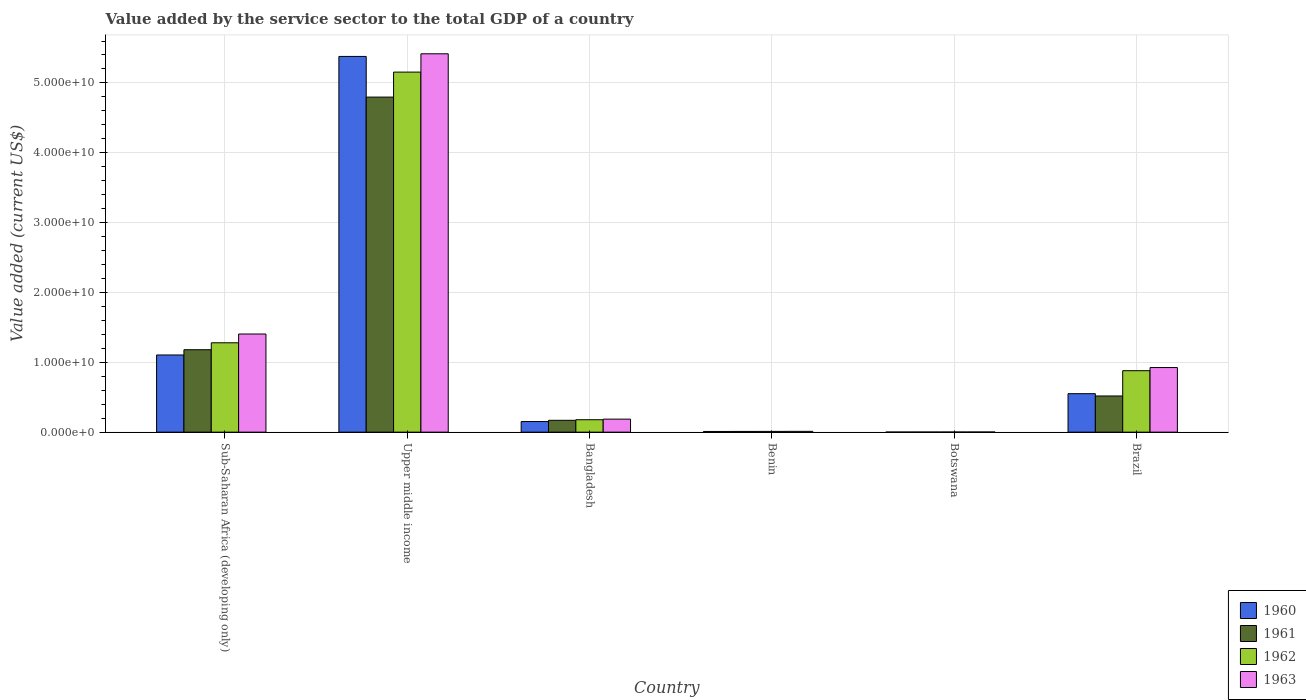How many different coloured bars are there?
Make the answer very short. 4. How many bars are there on the 5th tick from the right?
Your answer should be compact. 4. What is the label of the 1st group of bars from the left?
Your response must be concise. Sub-Saharan Africa (developing only). What is the value added by the service sector to the total GDP in 1962 in Bangladesh?
Give a very brief answer. 1.78e+09. Across all countries, what is the maximum value added by the service sector to the total GDP in 1960?
Give a very brief answer. 5.38e+1. Across all countries, what is the minimum value added by the service sector to the total GDP in 1961?
Provide a succinct answer. 1.51e+07. In which country was the value added by the service sector to the total GDP in 1962 maximum?
Your answer should be compact. Upper middle income. In which country was the value added by the service sector to the total GDP in 1961 minimum?
Make the answer very short. Botswana. What is the total value added by the service sector to the total GDP in 1962 in the graph?
Keep it short and to the point. 7.50e+1. What is the difference between the value added by the service sector to the total GDP in 1963 in Botswana and that in Upper middle income?
Ensure brevity in your answer.  -5.42e+1. What is the difference between the value added by the service sector to the total GDP in 1961 in Benin and the value added by the service sector to the total GDP in 1963 in Sub-Saharan Africa (developing only)?
Provide a succinct answer. -1.39e+1. What is the average value added by the service sector to the total GDP in 1962 per country?
Ensure brevity in your answer.  1.25e+1. What is the difference between the value added by the service sector to the total GDP of/in 1960 and value added by the service sector to the total GDP of/in 1963 in Sub-Saharan Africa (developing only)?
Your answer should be very brief. -3.00e+09. In how many countries, is the value added by the service sector to the total GDP in 1962 greater than 16000000000 US$?
Your answer should be compact. 1. What is the ratio of the value added by the service sector to the total GDP in 1962 in Botswana to that in Upper middle income?
Offer a very short reply. 0. What is the difference between the highest and the second highest value added by the service sector to the total GDP in 1960?
Offer a very short reply. -4.83e+1. What is the difference between the highest and the lowest value added by the service sector to the total GDP in 1963?
Your response must be concise. 5.42e+1. In how many countries, is the value added by the service sector to the total GDP in 1961 greater than the average value added by the service sector to the total GDP in 1961 taken over all countries?
Your answer should be very brief. 2. Is it the case that in every country, the sum of the value added by the service sector to the total GDP in 1963 and value added by the service sector to the total GDP in 1960 is greater than the sum of value added by the service sector to the total GDP in 1961 and value added by the service sector to the total GDP in 1962?
Provide a succinct answer. No. What does the 1st bar from the right in Bangladesh represents?
Offer a very short reply. 1963. How many bars are there?
Your response must be concise. 24. Are all the bars in the graph horizontal?
Ensure brevity in your answer.  No. How many countries are there in the graph?
Your response must be concise. 6. What is the difference between two consecutive major ticks on the Y-axis?
Provide a short and direct response. 1.00e+1. Does the graph contain any zero values?
Offer a very short reply. No. Does the graph contain grids?
Provide a short and direct response. Yes. How are the legend labels stacked?
Keep it short and to the point. Vertical. What is the title of the graph?
Give a very brief answer. Value added by the service sector to the total GDP of a country. Does "1971" appear as one of the legend labels in the graph?
Offer a very short reply. No. What is the label or title of the Y-axis?
Your response must be concise. Value added (current US$). What is the Value added (current US$) of 1960 in Sub-Saharan Africa (developing only)?
Provide a succinct answer. 1.10e+1. What is the Value added (current US$) of 1961 in Sub-Saharan Africa (developing only)?
Your answer should be compact. 1.18e+1. What is the Value added (current US$) of 1962 in Sub-Saharan Africa (developing only)?
Offer a very short reply. 1.28e+1. What is the Value added (current US$) in 1963 in Sub-Saharan Africa (developing only)?
Ensure brevity in your answer.  1.41e+1. What is the Value added (current US$) in 1960 in Upper middle income?
Provide a succinct answer. 5.38e+1. What is the Value added (current US$) in 1961 in Upper middle income?
Offer a terse response. 4.80e+1. What is the Value added (current US$) in 1962 in Upper middle income?
Make the answer very short. 5.16e+1. What is the Value added (current US$) of 1963 in Upper middle income?
Offer a terse response. 5.42e+1. What is the Value added (current US$) in 1960 in Bangladesh?
Your answer should be very brief. 1.52e+09. What is the Value added (current US$) of 1961 in Bangladesh?
Provide a short and direct response. 1.70e+09. What is the Value added (current US$) in 1962 in Bangladesh?
Offer a terse response. 1.78e+09. What is the Value added (current US$) of 1963 in Bangladesh?
Provide a succinct answer. 1.86e+09. What is the Value added (current US$) in 1960 in Benin?
Provide a short and direct response. 9.87e+07. What is the Value added (current US$) of 1961 in Benin?
Offer a very short reply. 1.04e+08. What is the Value added (current US$) of 1962 in Benin?
Ensure brevity in your answer.  1.08e+08. What is the Value added (current US$) in 1963 in Benin?
Offer a very short reply. 1.14e+08. What is the Value added (current US$) in 1960 in Botswana?
Keep it short and to the point. 1.31e+07. What is the Value added (current US$) in 1961 in Botswana?
Keep it short and to the point. 1.51e+07. What is the Value added (current US$) in 1962 in Botswana?
Offer a terse response. 1.73e+07. What is the Value added (current US$) in 1963 in Botswana?
Your response must be concise. 1.93e+07. What is the Value added (current US$) of 1960 in Brazil?
Your answer should be compact. 5.51e+09. What is the Value added (current US$) in 1961 in Brazil?
Provide a succinct answer. 5.18e+09. What is the Value added (current US$) of 1962 in Brazil?
Give a very brief answer. 8.80e+09. What is the Value added (current US$) of 1963 in Brazil?
Offer a terse response. 9.25e+09. Across all countries, what is the maximum Value added (current US$) of 1960?
Give a very brief answer. 5.38e+1. Across all countries, what is the maximum Value added (current US$) of 1961?
Ensure brevity in your answer.  4.80e+1. Across all countries, what is the maximum Value added (current US$) of 1962?
Your answer should be compact. 5.16e+1. Across all countries, what is the maximum Value added (current US$) in 1963?
Give a very brief answer. 5.42e+1. Across all countries, what is the minimum Value added (current US$) of 1960?
Offer a very short reply. 1.31e+07. Across all countries, what is the minimum Value added (current US$) of 1961?
Provide a succinct answer. 1.51e+07. Across all countries, what is the minimum Value added (current US$) of 1962?
Provide a succinct answer. 1.73e+07. Across all countries, what is the minimum Value added (current US$) of 1963?
Give a very brief answer. 1.93e+07. What is the total Value added (current US$) in 1960 in the graph?
Make the answer very short. 7.20e+1. What is the total Value added (current US$) of 1961 in the graph?
Your answer should be compact. 6.68e+1. What is the total Value added (current US$) in 1962 in the graph?
Make the answer very short. 7.50e+1. What is the total Value added (current US$) of 1963 in the graph?
Provide a succinct answer. 7.95e+1. What is the difference between the Value added (current US$) of 1960 in Sub-Saharan Africa (developing only) and that in Upper middle income?
Give a very brief answer. -4.27e+1. What is the difference between the Value added (current US$) in 1961 in Sub-Saharan Africa (developing only) and that in Upper middle income?
Your answer should be compact. -3.62e+1. What is the difference between the Value added (current US$) of 1962 in Sub-Saharan Africa (developing only) and that in Upper middle income?
Provide a short and direct response. -3.88e+1. What is the difference between the Value added (current US$) of 1963 in Sub-Saharan Africa (developing only) and that in Upper middle income?
Provide a short and direct response. -4.01e+1. What is the difference between the Value added (current US$) of 1960 in Sub-Saharan Africa (developing only) and that in Bangladesh?
Ensure brevity in your answer.  9.53e+09. What is the difference between the Value added (current US$) of 1961 in Sub-Saharan Africa (developing only) and that in Bangladesh?
Provide a short and direct response. 1.01e+1. What is the difference between the Value added (current US$) in 1962 in Sub-Saharan Africa (developing only) and that in Bangladesh?
Offer a terse response. 1.10e+1. What is the difference between the Value added (current US$) in 1963 in Sub-Saharan Africa (developing only) and that in Bangladesh?
Offer a terse response. 1.22e+1. What is the difference between the Value added (current US$) of 1960 in Sub-Saharan Africa (developing only) and that in Benin?
Give a very brief answer. 1.10e+1. What is the difference between the Value added (current US$) of 1961 in Sub-Saharan Africa (developing only) and that in Benin?
Keep it short and to the point. 1.17e+1. What is the difference between the Value added (current US$) of 1962 in Sub-Saharan Africa (developing only) and that in Benin?
Your response must be concise. 1.27e+1. What is the difference between the Value added (current US$) of 1963 in Sub-Saharan Africa (developing only) and that in Benin?
Offer a very short reply. 1.39e+1. What is the difference between the Value added (current US$) of 1960 in Sub-Saharan Africa (developing only) and that in Botswana?
Offer a very short reply. 1.10e+1. What is the difference between the Value added (current US$) in 1961 in Sub-Saharan Africa (developing only) and that in Botswana?
Your answer should be compact. 1.18e+1. What is the difference between the Value added (current US$) of 1962 in Sub-Saharan Africa (developing only) and that in Botswana?
Ensure brevity in your answer.  1.28e+1. What is the difference between the Value added (current US$) in 1963 in Sub-Saharan Africa (developing only) and that in Botswana?
Provide a succinct answer. 1.40e+1. What is the difference between the Value added (current US$) of 1960 in Sub-Saharan Africa (developing only) and that in Brazil?
Your answer should be compact. 5.54e+09. What is the difference between the Value added (current US$) of 1961 in Sub-Saharan Africa (developing only) and that in Brazil?
Provide a succinct answer. 6.62e+09. What is the difference between the Value added (current US$) in 1962 in Sub-Saharan Africa (developing only) and that in Brazil?
Provide a short and direct response. 4.00e+09. What is the difference between the Value added (current US$) in 1963 in Sub-Saharan Africa (developing only) and that in Brazil?
Provide a succinct answer. 4.80e+09. What is the difference between the Value added (current US$) of 1960 in Upper middle income and that in Bangladesh?
Your response must be concise. 5.23e+1. What is the difference between the Value added (current US$) in 1961 in Upper middle income and that in Bangladesh?
Provide a succinct answer. 4.63e+1. What is the difference between the Value added (current US$) of 1962 in Upper middle income and that in Bangladesh?
Provide a succinct answer. 4.98e+1. What is the difference between the Value added (current US$) in 1963 in Upper middle income and that in Bangladesh?
Offer a terse response. 5.23e+1. What is the difference between the Value added (current US$) in 1960 in Upper middle income and that in Benin?
Offer a terse response. 5.37e+1. What is the difference between the Value added (current US$) in 1961 in Upper middle income and that in Benin?
Your answer should be very brief. 4.79e+1. What is the difference between the Value added (current US$) in 1962 in Upper middle income and that in Benin?
Keep it short and to the point. 5.14e+1. What is the difference between the Value added (current US$) of 1963 in Upper middle income and that in Benin?
Make the answer very short. 5.41e+1. What is the difference between the Value added (current US$) in 1960 in Upper middle income and that in Botswana?
Keep it short and to the point. 5.38e+1. What is the difference between the Value added (current US$) in 1961 in Upper middle income and that in Botswana?
Ensure brevity in your answer.  4.80e+1. What is the difference between the Value added (current US$) of 1962 in Upper middle income and that in Botswana?
Offer a terse response. 5.15e+1. What is the difference between the Value added (current US$) of 1963 in Upper middle income and that in Botswana?
Offer a terse response. 5.42e+1. What is the difference between the Value added (current US$) in 1960 in Upper middle income and that in Brazil?
Ensure brevity in your answer.  4.83e+1. What is the difference between the Value added (current US$) of 1961 in Upper middle income and that in Brazil?
Provide a short and direct response. 4.28e+1. What is the difference between the Value added (current US$) of 1962 in Upper middle income and that in Brazil?
Make the answer very short. 4.28e+1. What is the difference between the Value added (current US$) in 1963 in Upper middle income and that in Brazil?
Ensure brevity in your answer.  4.49e+1. What is the difference between the Value added (current US$) of 1960 in Bangladesh and that in Benin?
Provide a short and direct response. 1.42e+09. What is the difference between the Value added (current US$) in 1961 in Bangladesh and that in Benin?
Make the answer very short. 1.59e+09. What is the difference between the Value added (current US$) of 1962 in Bangladesh and that in Benin?
Make the answer very short. 1.67e+09. What is the difference between the Value added (current US$) of 1963 in Bangladesh and that in Benin?
Your response must be concise. 1.75e+09. What is the difference between the Value added (current US$) in 1960 in Bangladesh and that in Botswana?
Keep it short and to the point. 1.51e+09. What is the difference between the Value added (current US$) of 1961 in Bangladesh and that in Botswana?
Offer a terse response. 1.68e+09. What is the difference between the Value added (current US$) in 1962 in Bangladesh and that in Botswana?
Provide a succinct answer. 1.76e+09. What is the difference between the Value added (current US$) of 1963 in Bangladesh and that in Botswana?
Provide a succinct answer. 1.85e+09. What is the difference between the Value added (current US$) of 1960 in Bangladesh and that in Brazil?
Provide a short and direct response. -3.99e+09. What is the difference between the Value added (current US$) in 1961 in Bangladesh and that in Brazil?
Your response must be concise. -3.48e+09. What is the difference between the Value added (current US$) of 1962 in Bangladesh and that in Brazil?
Give a very brief answer. -7.02e+09. What is the difference between the Value added (current US$) of 1963 in Bangladesh and that in Brazil?
Make the answer very short. -7.38e+09. What is the difference between the Value added (current US$) of 1960 in Benin and that in Botswana?
Give a very brief answer. 8.55e+07. What is the difference between the Value added (current US$) of 1961 in Benin and that in Botswana?
Give a very brief answer. 8.86e+07. What is the difference between the Value added (current US$) of 1962 in Benin and that in Botswana?
Your answer should be compact. 9.03e+07. What is the difference between the Value added (current US$) of 1963 in Benin and that in Botswana?
Offer a terse response. 9.45e+07. What is the difference between the Value added (current US$) of 1960 in Benin and that in Brazil?
Give a very brief answer. -5.41e+09. What is the difference between the Value added (current US$) in 1961 in Benin and that in Brazil?
Keep it short and to the point. -5.07e+09. What is the difference between the Value added (current US$) of 1962 in Benin and that in Brazil?
Your answer should be compact. -8.69e+09. What is the difference between the Value added (current US$) of 1963 in Benin and that in Brazil?
Offer a very short reply. -9.13e+09. What is the difference between the Value added (current US$) of 1960 in Botswana and that in Brazil?
Provide a short and direct response. -5.50e+09. What is the difference between the Value added (current US$) of 1961 in Botswana and that in Brazil?
Provide a succinct answer. -5.16e+09. What is the difference between the Value added (current US$) of 1962 in Botswana and that in Brazil?
Provide a short and direct response. -8.78e+09. What is the difference between the Value added (current US$) of 1963 in Botswana and that in Brazil?
Provide a succinct answer. -9.23e+09. What is the difference between the Value added (current US$) of 1960 in Sub-Saharan Africa (developing only) and the Value added (current US$) of 1961 in Upper middle income?
Your response must be concise. -3.69e+1. What is the difference between the Value added (current US$) in 1960 in Sub-Saharan Africa (developing only) and the Value added (current US$) in 1962 in Upper middle income?
Give a very brief answer. -4.05e+1. What is the difference between the Value added (current US$) in 1960 in Sub-Saharan Africa (developing only) and the Value added (current US$) in 1963 in Upper middle income?
Your answer should be very brief. -4.31e+1. What is the difference between the Value added (current US$) of 1961 in Sub-Saharan Africa (developing only) and the Value added (current US$) of 1962 in Upper middle income?
Your answer should be compact. -3.97e+1. What is the difference between the Value added (current US$) in 1961 in Sub-Saharan Africa (developing only) and the Value added (current US$) in 1963 in Upper middle income?
Your answer should be compact. -4.24e+1. What is the difference between the Value added (current US$) in 1962 in Sub-Saharan Africa (developing only) and the Value added (current US$) in 1963 in Upper middle income?
Provide a succinct answer. -4.14e+1. What is the difference between the Value added (current US$) in 1960 in Sub-Saharan Africa (developing only) and the Value added (current US$) in 1961 in Bangladesh?
Your answer should be very brief. 9.35e+09. What is the difference between the Value added (current US$) in 1960 in Sub-Saharan Africa (developing only) and the Value added (current US$) in 1962 in Bangladesh?
Your response must be concise. 9.27e+09. What is the difference between the Value added (current US$) in 1960 in Sub-Saharan Africa (developing only) and the Value added (current US$) in 1963 in Bangladesh?
Give a very brief answer. 9.19e+09. What is the difference between the Value added (current US$) in 1961 in Sub-Saharan Africa (developing only) and the Value added (current US$) in 1962 in Bangladesh?
Provide a succinct answer. 1.00e+1. What is the difference between the Value added (current US$) in 1961 in Sub-Saharan Africa (developing only) and the Value added (current US$) in 1963 in Bangladesh?
Ensure brevity in your answer.  9.94e+09. What is the difference between the Value added (current US$) in 1962 in Sub-Saharan Africa (developing only) and the Value added (current US$) in 1963 in Bangladesh?
Your answer should be compact. 1.09e+1. What is the difference between the Value added (current US$) in 1960 in Sub-Saharan Africa (developing only) and the Value added (current US$) in 1961 in Benin?
Your answer should be very brief. 1.09e+1. What is the difference between the Value added (current US$) in 1960 in Sub-Saharan Africa (developing only) and the Value added (current US$) in 1962 in Benin?
Offer a terse response. 1.09e+1. What is the difference between the Value added (current US$) in 1960 in Sub-Saharan Africa (developing only) and the Value added (current US$) in 1963 in Benin?
Offer a very short reply. 1.09e+1. What is the difference between the Value added (current US$) of 1961 in Sub-Saharan Africa (developing only) and the Value added (current US$) of 1962 in Benin?
Provide a succinct answer. 1.17e+1. What is the difference between the Value added (current US$) of 1961 in Sub-Saharan Africa (developing only) and the Value added (current US$) of 1963 in Benin?
Ensure brevity in your answer.  1.17e+1. What is the difference between the Value added (current US$) of 1962 in Sub-Saharan Africa (developing only) and the Value added (current US$) of 1963 in Benin?
Keep it short and to the point. 1.27e+1. What is the difference between the Value added (current US$) in 1960 in Sub-Saharan Africa (developing only) and the Value added (current US$) in 1961 in Botswana?
Your answer should be very brief. 1.10e+1. What is the difference between the Value added (current US$) of 1960 in Sub-Saharan Africa (developing only) and the Value added (current US$) of 1962 in Botswana?
Your answer should be very brief. 1.10e+1. What is the difference between the Value added (current US$) of 1960 in Sub-Saharan Africa (developing only) and the Value added (current US$) of 1963 in Botswana?
Provide a succinct answer. 1.10e+1. What is the difference between the Value added (current US$) of 1961 in Sub-Saharan Africa (developing only) and the Value added (current US$) of 1962 in Botswana?
Give a very brief answer. 1.18e+1. What is the difference between the Value added (current US$) of 1961 in Sub-Saharan Africa (developing only) and the Value added (current US$) of 1963 in Botswana?
Make the answer very short. 1.18e+1. What is the difference between the Value added (current US$) in 1962 in Sub-Saharan Africa (developing only) and the Value added (current US$) in 1963 in Botswana?
Your answer should be compact. 1.28e+1. What is the difference between the Value added (current US$) in 1960 in Sub-Saharan Africa (developing only) and the Value added (current US$) in 1961 in Brazil?
Offer a very short reply. 5.87e+09. What is the difference between the Value added (current US$) in 1960 in Sub-Saharan Africa (developing only) and the Value added (current US$) in 1962 in Brazil?
Provide a succinct answer. 2.25e+09. What is the difference between the Value added (current US$) of 1960 in Sub-Saharan Africa (developing only) and the Value added (current US$) of 1963 in Brazil?
Make the answer very short. 1.80e+09. What is the difference between the Value added (current US$) in 1961 in Sub-Saharan Africa (developing only) and the Value added (current US$) in 1962 in Brazil?
Ensure brevity in your answer.  3.00e+09. What is the difference between the Value added (current US$) in 1961 in Sub-Saharan Africa (developing only) and the Value added (current US$) in 1963 in Brazil?
Offer a very short reply. 2.55e+09. What is the difference between the Value added (current US$) in 1962 in Sub-Saharan Africa (developing only) and the Value added (current US$) in 1963 in Brazil?
Your answer should be compact. 3.55e+09. What is the difference between the Value added (current US$) in 1960 in Upper middle income and the Value added (current US$) in 1961 in Bangladesh?
Make the answer very short. 5.21e+1. What is the difference between the Value added (current US$) of 1960 in Upper middle income and the Value added (current US$) of 1962 in Bangladesh?
Your answer should be very brief. 5.20e+1. What is the difference between the Value added (current US$) in 1960 in Upper middle income and the Value added (current US$) in 1963 in Bangladesh?
Provide a short and direct response. 5.19e+1. What is the difference between the Value added (current US$) in 1961 in Upper middle income and the Value added (current US$) in 1962 in Bangladesh?
Provide a short and direct response. 4.62e+1. What is the difference between the Value added (current US$) of 1961 in Upper middle income and the Value added (current US$) of 1963 in Bangladesh?
Your answer should be very brief. 4.61e+1. What is the difference between the Value added (current US$) of 1962 in Upper middle income and the Value added (current US$) of 1963 in Bangladesh?
Provide a succinct answer. 4.97e+1. What is the difference between the Value added (current US$) in 1960 in Upper middle income and the Value added (current US$) in 1961 in Benin?
Your answer should be very brief. 5.37e+1. What is the difference between the Value added (current US$) of 1960 in Upper middle income and the Value added (current US$) of 1962 in Benin?
Make the answer very short. 5.37e+1. What is the difference between the Value added (current US$) of 1960 in Upper middle income and the Value added (current US$) of 1963 in Benin?
Give a very brief answer. 5.37e+1. What is the difference between the Value added (current US$) of 1961 in Upper middle income and the Value added (current US$) of 1962 in Benin?
Offer a terse response. 4.79e+1. What is the difference between the Value added (current US$) in 1961 in Upper middle income and the Value added (current US$) in 1963 in Benin?
Your answer should be very brief. 4.79e+1. What is the difference between the Value added (current US$) in 1962 in Upper middle income and the Value added (current US$) in 1963 in Benin?
Ensure brevity in your answer.  5.14e+1. What is the difference between the Value added (current US$) in 1960 in Upper middle income and the Value added (current US$) in 1961 in Botswana?
Offer a very short reply. 5.38e+1. What is the difference between the Value added (current US$) in 1960 in Upper middle income and the Value added (current US$) in 1962 in Botswana?
Offer a very short reply. 5.38e+1. What is the difference between the Value added (current US$) of 1960 in Upper middle income and the Value added (current US$) of 1963 in Botswana?
Offer a very short reply. 5.38e+1. What is the difference between the Value added (current US$) of 1961 in Upper middle income and the Value added (current US$) of 1962 in Botswana?
Keep it short and to the point. 4.80e+1. What is the difference between the Value added (current US$) of 1961 in Upper middle income and the Value added (current US$) of 1963 in Botswana?
Offer a very short reply. 4.80e+1. What is the difference between the Value added (current US$) in 1962 in Upper middle income and the Value added (current US$) in 1963 in Botswana?
Your response must be concise. 5.15e+1. What is the difference between the Value added (current US$) of 1960 in Upper middle income and the Value added (current US$) of 1961 in Brazil?
Your answer should be compact. 4.86e+1. What is the difference between the Value added (current US$) of 1960 in Upper middle income and the Value added (current US$) of 1962 in Brazil?
Ensure brevity in your answer.  4.50e+1. What is the difference between the Value added (current US$) of 1960 in Upper middle income and the Value added (current US$) of 1963 in Brazil?
Provide a succinct answer. 4.45e+1. What is the difference between the Value added (current US$) in 1961 in Upper middle income and the Value added (current US$) in 1962 in Brazil?
Make the answer very short. 3.92e+1. What is the difference between the Value added (current US$) of 1961 in Upper middle income and the Value added (current US$) of 1963 in Brazil?
Make the answer very short. 3.87e+1. What is the difference between the Value added (current US$) in 1962 in Upper middle income and the Value added (current US$) in 1963 in Brazil?
Your answer should be compact. 4.23e+1. What is the difference between the Value added (current US$) in 1960 in Bangladesh and the Value added (current US$) in 1961 in Benin?
Offer a very short reply. 1.42e+09. What is the difference between the Value added (current US$) of 1960 in Bangladesh and the Value added (current US$) of 1962 in Benin?
Provide a succinct answer. 1.41e+09. What is the difference between the Value added (current US$) of 1960 in Bangladesh and the Value added (current US$) of 1963 in Benin?
Keep it short and to the point. 1.41e+09. What is the difference between the Value added (current US$) of 1961 in Bangladesh and the Value added (current US$) of 1962 in Benin?
Offer a terse response. 1.59e+09. What is the difference between the Value added (current US$) in 1961 in Bangladesh and the Value added (current US$) in 1963 in Benin?
Keep it short and to the point. 1.58e+09. What is the difference between the Value added (current US$) of 1962 in Bangladesh and the Value added (current US$) of 1963 in Benin?
Your answer should be compact. 1.67e+09. What is the difference between the Value added (current US$) in 1960 in Bangladesh and the Value added (current US$) in 1961 in Botswana?
Make the answer very short. 1.50e+09. What is the difference between the Value added (current US$) of 1960 in Bangladesh and the Value added (current US$) of 1962 in Botswana?
Offer a very short reply. 1.50e+09. What is the difference between the Value added (current US$) of 1960 in Bangladesh and the Value added (current US$) of 1963 in Botswana?
Your answer should be compact. 1.50e+09. What is the difference between the Value added (current US$) in 1961 in Bangladesh and the Value added (current US$) in 1962 in Botswana?
Keep it short and to the point. 1.68e+09. What is the difference between the Value added (current US$) in 1961 in Bangladesh and the Value added (current US$) in 1963 in Botswana?
Your response must be concise. 1.68e+09. What is the difference between the Value added (current US$) of 1962 in Bangladesh and the Value added (current US$) of 1963 in Botswana?
Keep it short and to the point. 1.76e+09. What is the difference between the Value added (current US$) in 1960 in Bangladesh and the Value added (current US$) in 1961 in Brazil?
Your answer should be compact. -3.66e+09. What is the difference between the Value added (current US$) in 1960 in Bangladesh and the Value added (current US$) in 1962 in Brazil?
Keep it short and to the point. -7.28e+09. What is the difference between the Value added (current US$) of 1960 in Bangladesh and the Value added (current US$) of 1963 in Brazil?
Provide a succinct answer. -7.73e+09. What is the difference between the Value added (current US$) of 1961 in Bangladesh and the Value added (current US$) of 1962 in Brazil?
Provide a succinct answer. -7.10e+09. What is the difference between the Value added (current US$) in 1961 in Bangladesh and the Value added (current US$) in 1963 in Brazil?
Ensure brevity in your answer.  -7.55e+09. What is the difference between the Value added (current US$) in 1962 in Bangladesh and the Value added (current US$) in 1963 in Brazil?
Offer a terse response. -7.47e+09. What is the difference between the Value added (current US$) in 1960 in Benin and the Value added (current US$) in 1961 in Botswana?
Provide a succinct answer. 8.36e+07. What is the difference between the Value added (current US$) in 1960 in Benin and the Value added (current US$) in 1962 in Botswana?
Provide a short and direct response. 8.14e+07. What is the difference between the Value added (current US$) in 1960 in Benin and the Value added (current US$) in 1963 in Botswana?
Your response must be concise. 7.94e+07. What is the difference between the Value added (current US$) of 1961 in Benin and the Value added (current US$) of 1962 in Botswana?
Provide a short and direct response. 8.64e+07. What is the difference between the Value added (current US$) of 1961 in Benin and the Value added (current US$) of 1963 in Botswana?
Provide a short and direct response. 8.44e+07. What is the difference between the Value added (current US$) of 1962 in Benin and the Value added (current US$) of 1963 in Botswana?
Offer a terse response. 8.83e+07. What is the difference between the Value added (current US$) of 1960 in Benin and the Value added (current US$) of 1961 in Brazil?
Your response must be concise. -5.08e+09. What is the difference between the Value added (current US$) of 1960 in Benin and the Value added (current US$) of 1962 in Brazil?
Offer a terse response. -8.70e+09. What is the difference between the Value added (current US$) in 1960 in Benin and the Value added (current US$) in 1963 in Brazil?
Your answer should be very brief. -9.15e+09. What is the difference between the Value added (current US$) in 1961 in Benin and the Value added (current US$) in 1962 in Brazil?
Provide a succinct answer. -8.70e+09. What is the difference between the Value added (current US$) of 1961 in Benin and the Value added (current US$) of 1963 in Brazil?
Provide a succinct answer. -9.14e+09. What is the difference between the Value added (current US$) of 1962 in Benin and the Value added (current US$) of 1963 in Brazil?
Your answer should be compact. -9.14e+09. What is the difference between the Value added (current US$) in 1960 in Botswana and the Value added (current US$) in 1961 in Brazil?
Provide a short and direct response. -5.17e+09. What is the difference between the Value added (current US$) of 1960 in Botswana and the Value added (current US$) of 1962 in Brazil?
Keep it short and to the point. -8.79e+09. What is the difference between the Value added (current US$) in 1960 in Botswana and the Value added (current US$) in 1963 in Brazil?
Offer a terse response. -9.24e+09. What is the difference between the Value added (current US$) of 1961 in Botswana and the Value added (current US$) of 1962 in Brazil?
Your response must be concise. -8.78e+09. What is the difference between the Value added (current US$) of 1961 in Botswana and the Value added (current US$) of 1963 in Brazil?
Your answer should be very brief. -9.23e+09. What is the difference between the Value added (current US$) in 1962 in Botswana and the Value added (current US$) in 1963 in Brazil?
Your answer should be very brief. -9.23e+09. What is the average Value added (current US$) of 1960 per country?
Keep it short and to the point. 1.20e+1. What is the average Value added (current US$) of 1961 per country?
Give a very brief answer. 1.11e+1. What is the average Value added (current US$) in 1962 per country?
Your answer should be very brief. 1.25e+1. What is the average Value added (current US$) of 1963 per country?
Offer a terse response. 1.32e+1. What is the difference between the Value added (current US$) of 1960 and Value added (current US$) of 1961 in Sub-Saharan Africa (developing only)?
Your answer should be very brief. -7.52e+08. What is the difference between the Value added (current US$) in 1960 and Value added (current US$) in 1962 in Sub-Saharan Africa (developing only)?
Offer a terse response. -1.75e+09. What is the difference between the Value added (current US$) of 1960 and Value added (current US$) of 1963 in Sub-Saharan Africa (developing only)?
Make the answer very short. -3.00e+09. What is the difference between the Value added (current US$) of 1961 and Value added (current US$) of 1962 in Sub-Saharan Africa (developing only)?
Offer a terse response. -9.93e+08. What is the difference between the Value added (current US$) of 1961 and Value added (current US$) of 1963 in Sub-Saharan Africa (developing only)?
Provide a succinct answer. -2.25e+09. What is the difference between the Value added (current US$) of 1962 and Value added (current US$) of 1963 in Sub-Saharan Africa (developing only)?
Provide a succinct answer. -1.26e+09. What is the difference between the Value added (current US$) in 1960 and Value added (current US$) in 1961 in Upper middle income?
Keep it short and to the point. 5.82e+09. What is the difference between the Value added (current US$) in 1960 and Value added (current US$) in 1962 in Upper middle income?
Your response must be concise. 2.24e+09. What is the difference between the Value added (current US$) in 1960 and Value added (current US$) in 1963 in Upper middle income?
Offer a terse response. -3.78e+08. What is the difference between the Value added (current US$) in 1961 and Value added (current US$) in 1962 in Upper middle income?
Make the answer very short. -3.58e+09. What is the difference between the Value added (current US$) of 1961 and Value added (current US$) of 1963 in Upper middle income?
Provide a short and direct response. -6.20e+09. What is the difference between the Value added (current US$) in 1962 and Value added (current US$) in 1963 in Upper middle income?
Offer a terse response. -2.62e+09. What is the difference between the Value added (current US$) of 1960 and Value added (current US$) of 1961 in Bangladesh?
Your answer should be compact. -1.77e+08. What is the difference between the Value added (current US$) in 1960 and Value added (current US$) in 1962 in Bangladesh?
Give a very brief answer. -2.60e+08. What is the difference between the Value added (current US$) in 1960 and Value added (current US$) in 1963 in Bangladesh?
Your answer should be compact. -3.45e+08. What is the difference between the Value added (current US$) in 1961 and Value added (current US$) in 1962 in Bangladesh?
Provide a short and direct response. -8.27e+07. What is the difference between the Value added (current US$) in 1961 and Value added (current US$) in 1963 in Bangladesh?
Ensure brevity in your answer.  -1.68e+08. What is the difference between the Value added (current US$) of 1962 and Value added (current US$) of 1963 in Bangladesh?
Your response must be concise. -8.50e+07. What is the difference between the Value added (current US$) of 1960 and Value added (current US$) of 1961 in Benin?
Give a very brief answer. -5.02e+06. What is the difference between the Value added (current US$) in 1960 and Value added (current US$) in 1962 in Benin?
Give a very brief answer. -8.92e+06. What is the difference between the Value added (current US$) in 1960 and Value added (current US$) in 1963 in Benin?
Give a very brief answer. -1.51e+07. What is the difference between the Value added (current US$) of 1961 and Value added (current US$) of 1962 in Benin?
Your answer should be very brief. -3.90e+06. What is the difference between the Value added (current US$) in 1961 and Value added (current US$) in 1963 in Benin?
Your answer should be compact. -1.01e+07. What is the difference between the Value added (current US$) in 1962 and Value added (current US$) in 1963 in Benin?
Give a very brief answer. -6.21e+06. What is the difference between the Value added (current US$) of 1960 and Value added (current US$) of 1961 in Botswana?
Provide a succinct answer. -1.99e+06. What is the difference between the Value added (current US$) in 1960 and Value added (current US$) in 1962 in Botswana?
Provide a short and direct response. -4.17e+06. What is the difference between the Value added (current US$) of 1960 and Value added (current US$) of 1963 in Botswana?
Your response must be concise. -6.14e+06. What is the difference between the Value added (current US$) of 1961 and Value added (current US$) of 1962 in Botswana?
Offer a terse response. -2.18e+06. What is the difference between the Value added (current US$) of 1961 and Value added (current US$) of 1963 in Botswana?
Make the answer very short. -4.15e+06. What is the difference between the Value added (current US$) in 1962 and Value added (current US$) in 1963 in Botswana?
Make the answer very short. -1.97e+06. What is the difference between the Value added (current US$) of 1960 and Value added (current US$) of 1961 in Brazil?
Make the answer very short. 3.31e+08. What is the difference between the Value added (current US$) of 1960 and Value added (current US$) of 1962 in Brazil?
Provide a succinct answer. -3.29e+09. What is the difference between the Value added (current US$) in 1960 and Value added (current US$) in 1963 in Brazil?
Ensure brevity in your answer.  -3.74e+09. What is the difference between the Value added (current US$) in 1961 and Value added (current US$) in 1962 in Brazil?
Your answer should be very brief. -3.62e+09. What is the difference between the Value added (current US$) in 1961 and Value added (current US$) in 1963 in Brazil?
Make the answer very short. -4.07e+09. What is the difference between the Value added (current US$) of 1962 and Value added (current US$) of 1963 in Brazil?
Make the answer very short. -4.49e+08. What is the ratio of the Value added (current US$) in 1960 in Sub-Saharan Africa (developing only) to that in Upper middle income?
Offer a very short reply. 0.21. What is the ratio of the Value added (current US$) of 1961 in Sub-Saharan Africa (developing only) to that in Upper middle income?
Keep it short and to the point. 0.25. What is the ratio of the Value added (current US$) in 1962 in Sub-Saharan Africa (developing only) to that in Upper middle income?
Make the answer very short. 0.25. What is the ratio of the Value added (current US$) of 1963 in Sub-Saharan Africa (developing only) to that in Upper middle income?
Keep it short and to the point. 0.26. What is the ratio of the Value added (current US$) in 1960 in Sub-Saharan Africa (developing only) to that in Bangladesh?
Offer a terse response. 7.27. What is the ratio of the Value added (current US$) in 1961 in Sub-Saharan Africa (developing only) to that in Bangladesh?
Your answer should be very brief. 6.96. What is the ratio of the Value added (current US$) of 1962 in Sub-Saharan Africa (developing only) to that in Bangladesh?
Keep it short and to the point. 7.19. What is the ratio of the Value added (current US$) in 1963 in Sub-Saharan Africa (developing only) to that in Bangladesh?
Your response must be concise. 7.54. What is the ratio of the Value added (current US$) in 1960 in Sub-Saharan Africa (developing only) to that in Benin?
Your answer should be very brief. 112. What is the ratio of the Value added (current US$) in 1961 in Sub-Saharan Africa (developing only) to that in Benin?
Your answer should be very brief. 113.83. What is the ratio of the Value added (current US$) of 1962 in Sub-Saharan Africa (developing only) to that in Benin?
Ensure brevity in your answer.  118.94. What is the ratio of the Value added (current US$) in 1963 in Sub-Saharan Africa (developing only) to that in Benin?
Offer a terse response. 123.48. What is the ratio of the Value added (current US$) of 1960 in Sub-Saharan Africa (developing only) to that in Botswana?
Keep it short and to the point. 842.63. What is the ratio of the Value added (current US$) in 1961 in Sub-Saharan Africa (developing only) to that in Botswana?
Make the answer very short. 781.31. What is the ratio of the Value added (current US$) in 1962 in Sub-Saharan Africa (developing only) to that in Botswana?
Give a very brief answer. 740.25. What is the ratio of the Value added (current US$) of 1963 in Sub-Saharan Africa (developing only) to that in Botswana?
Your response must be concise. 729.9. What is the ratio of the Value added (current US$) in 1960 in Sub-Saharan Africa (developing only) to that in Brazil?
Give a very brief answer. 2.01. What is the ratio of the Value added (current US$) in 1961 in Sub-Saharan Africa (developing only) to that in Brazil?
Your answer should be very brief. 2.28. What is the ratio of the Value added (current US$) of 1962 in Sub-Saharan Africa (developing only) to that in Brazil?
Offer a terse response. 1.45. What is the ratio of the Value added (current US$) in 1963 in Sub-Saharan Africa (developing only) to that in Brazil?
Offer a very short reply. 1.52. What is the ratio of the Value added (current US$) in 1960 in Upper middle income to that in Bangladesh?
Offer a terse response. 35.4. What is the ratio of the Value added (current US$) of 1961 in Upper middle income to that in Bangladesh?
Your answer should be compact. 28.27. What is the ratio of the Value added (current US$) of 1962 in Upper middle income to that in Bangladesh?
Offer a terse response. 28.97. What is the ratio of the Value added (current US$) in 1963 in Upper middle income to that in Bangladesh?
Keep it short and to the point. 29.06. What is the ratio of the Value added (current US$) in 1960 in Upper middle income to that in Benin?
Your response must be concise. 545.27. What is the ratio of the Value added (current US$) of 1961 in Upper middle income to that in Benin?
Offer a very short reply. 462.69. What is the ratio of the Value added (current US$) in 1962 in Upper middle income to that in Benin?
Your answer should be compact. 479.2. What is the ratio of the Value added (current US$) of 1963 in Upper middle income to that in Benin?
Make the answer very short. 476.07. What is the ratio of the Value added (current US$) of 1960 in Upper middle income to that in Botswana?
Your answer should be very brief. 4102.17. What is the ratio of the Value added (current US$) in 1961 in Upper middle income to that in Botswana?
Your answer should be compact. 3175.77. What is the ratio of the Value added (current US$) of 1962 in Upper middle income to that in Botswana?
Give a very brief answer. 2982.43. What is the ratio of the Value added (current US$) of 1963 in Upper middle income to that in Botswana?
Ensure brevity in your answer.  2813.98. What is the ratio of the Value added (current US$) of 1960 in Upper middle income to that in Brazil?
Provide a succinct answer. 9.76. What is the ratio of the Value added (current US$) of 1961 in Upper middle income to that in Brazil?
Ensure brevity in your answer.  9.26. What is the ratio of the Value added (current US$) of 1962 in Upper middle income to that in Brazil?
Your answer should be compact. 5.86. What is the ratio of the Value added (current US$) of 1963 in Upper middle income to that in Brazil?
Ensure brevity in your answer.  5.86. What is the ratio of the Value added (current US$) in 1960 in Bangladesh to that in Benin?
Give a very brief answer. 15.41. What is the ratio of the Value added (current US$) in 1961 in Bangladesh to that in Benin?
Your response must be concise. 16.36. What is the ratio of the Value added (current US$) of 1962 in Bangladesh to that in Benin?
Offer a terse response. 16.54. What is the ratio of the Value added (current US$) of 1963 in Bangladesh to that in Benin?
Your answer should be compact. 16.38. What is the ratio of the Value added (current US$) in 1960 in Bangladesh to that in Botswana?
Your answer should be compact. 115.9. What is the ratio of the Value added (current US$) of 1961 in Bangladesh to that in Botswana?
Offer a terse response. 112.32. What is the ratio of the Value added (current US$) of 1962 in Bangladesh to that in Botswana?
Keep it short and to the point. 102.95. What is the ratio of the Value added (current US$) in 1963 in Bangladesh to that in Botswana?
Give a very brief answer. 96.85. What is the ratio of the Value added (current US$) of 1960 in Bangladesh to that in Brazil?
Provide a succinct answer. 0.28. What is the ratio of the Value added (current US$) in 1961 in Bangladesh to that in Brazil?
Offer a terse response. 0.33. What is the ratio of the Value added (current US$) of 1962 in Bangladesh to that in Brazil?
Provide a succinct answer. 0.2. What is the ratio of the Value added (current US$) of 1963 in Bangladesh to that in Brazil?
Keep it short and to the point. 0.2. What is the ratio of the Value added (current US$) in 1960 in Benin to that in Botswana?
Keep it short and to the point. 7.52. What is the ratio of the Value added (current US$) in 1961 in Benin to that in Botswana?
Your answer should be very brief. 6.86. What is the ratio of the Value added (current US$) in 1962 in Benin to that in Botswana?
Your answer should be compact. 6.22. What is the ratio of the Value added (current US$) of 1963 in Benin to that in Botswana?
Your answer should be very brief. 5.91. What is the ratio of the Value added (current US$) in 1960 in Benin to that in Brazil?
Ensure brevity in your answer.  0.02. What is the ratio of the Value added (current US$) in 1962 in Benin to that in Brazil?
Offer a terse response. 0.01. What is the ratio of the Value added (current US$) in 1963 in Benin to that in Brazil?
Your answer should be compact. 0.01. What is the ratio of the Value added (current US$) in 1960 in Botswana to that in Brazil?
Give a very brief answer. 0. What is the ratio of the Value added (current US$) of 1961 in Botswana to that in Brazil?
Your answer should be very brief. 0. What is the ratio of the Value added (current US$) of 1962 in Botswana to that in Brazil?
Your answer should be compact. 0. What is the ratio of the Value added (current US$) in 1963 in Botswana to that in Brazil?
Your response must be concise. 0. What is the difference between the highest and the second highest Value added (current US$) in 1960?
Keep it short and to the point. 4.27e+1. What is the difference between the highest and the second highest Value added (current US$) of 1961?
Provide a short and direct response. 3.62e+1. What is the difference between the highest and the second highest Value added (current US$) in 1962?
Your answer should be compact. 3.88e+1. What is the difference between the highest and the second highest Value added (current US$) in 1963?
Give a very brief answer. 4.01e+1. What is the difference between the highest and the lowest Value added (current US$) of 1960?
Your response must be concise. 5.38e+1. What is the difference between the highest and the lowest Value added (current US$) of 1961?
Give a very brief answer. 4.80e+1. What is the difference between the highest and the lowest Value added (current US$) in 1962?
Offer a very short reply. 5.15e+1. What is the difference between the highest and the lowest Value added (current US$) in 1963?
Provide a succinct answer. 5.42e+1. 